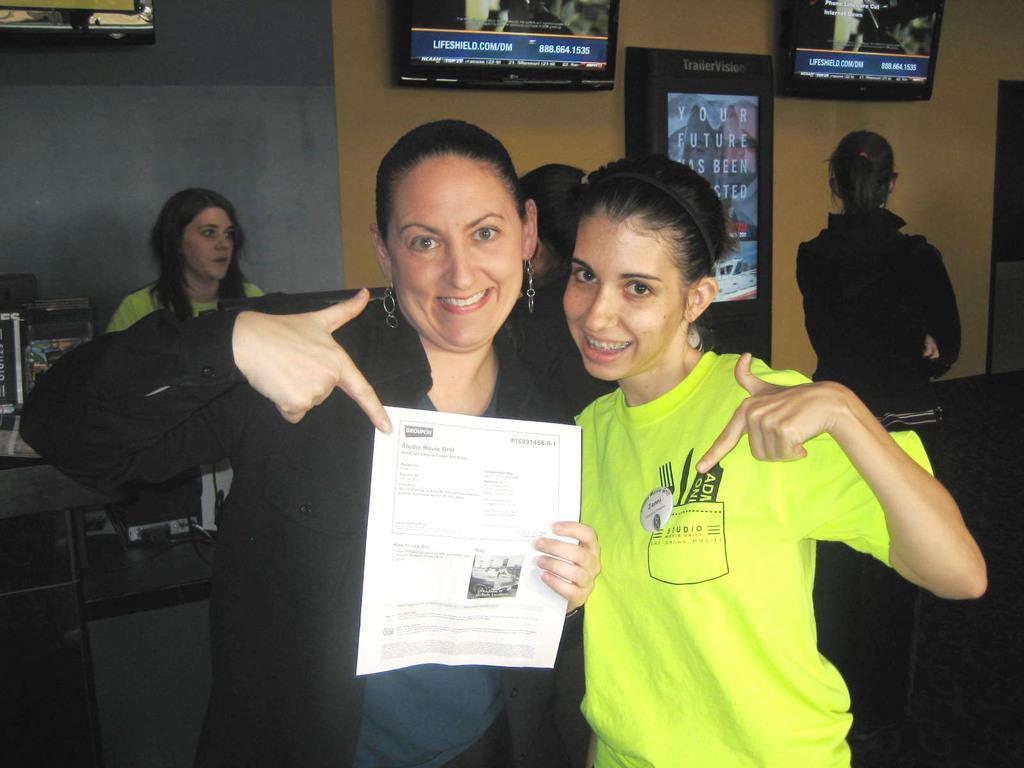In one or two sentences, can you explain what this image depicts? In this picture there are two women standing and smiling and she is holding a paper, behind these two women we can see people and objects. In the background of the image we can see screens and wall. 